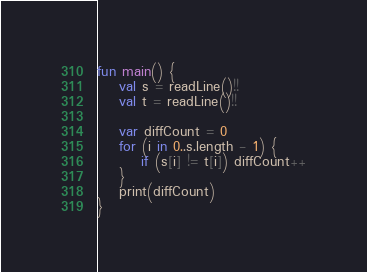Convert code to text. <code><loc_0><loc_0><loc_500><loc_500><_Kotlin_>fun main() {
    val s = readLine()!!
    val t = readLine()!!

    var diffCount = 0
    for (i in 0..s.length - 1) {
        if (s[i] != t[i]) diffCount++
    }
    print(diffCount)
}

</code> 